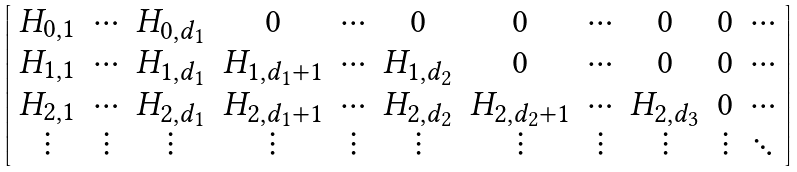<formula> <loc_0><loc_0><loc_500><loc_500>\left [ \begin{array} { c c c c c c c c c c c } H _ { 0 , 1 } & \cdots & H _ { 0 , d _ { 1 } } & 0 & \cdots & 0 & 0 & \cdots & 0 & 0 & \cdots \\ H _ { 1 , 1 } & \cdots & H _ { 1 , d _ { 1 } } & H _ { 1 , d _ { 1 } + 1 } & \cdots & H _ { 1 , d _ { 2 } } & 0 & \cdots & 0 & 0 & \cdots \\ H _ { 2 , 1 } & \cdots & H _ { 2 , d _ { 1 } } & H _ { 2 , d _ { 1 } + 1 } & \cdots & H _ { 2 , d _ { 2 } } & H _ { 2 , d _ { 2 } + 1 } & \cdots & H _ { 2 , d _ { 3 } } & 0 & \cdots \\ \vdots & \vdots & \vdots & \vdots & \vdots & \vdots & \vdots & \vdots & \vdots & \vdots & \ddots \\ \end{array} \right ]</formula> 